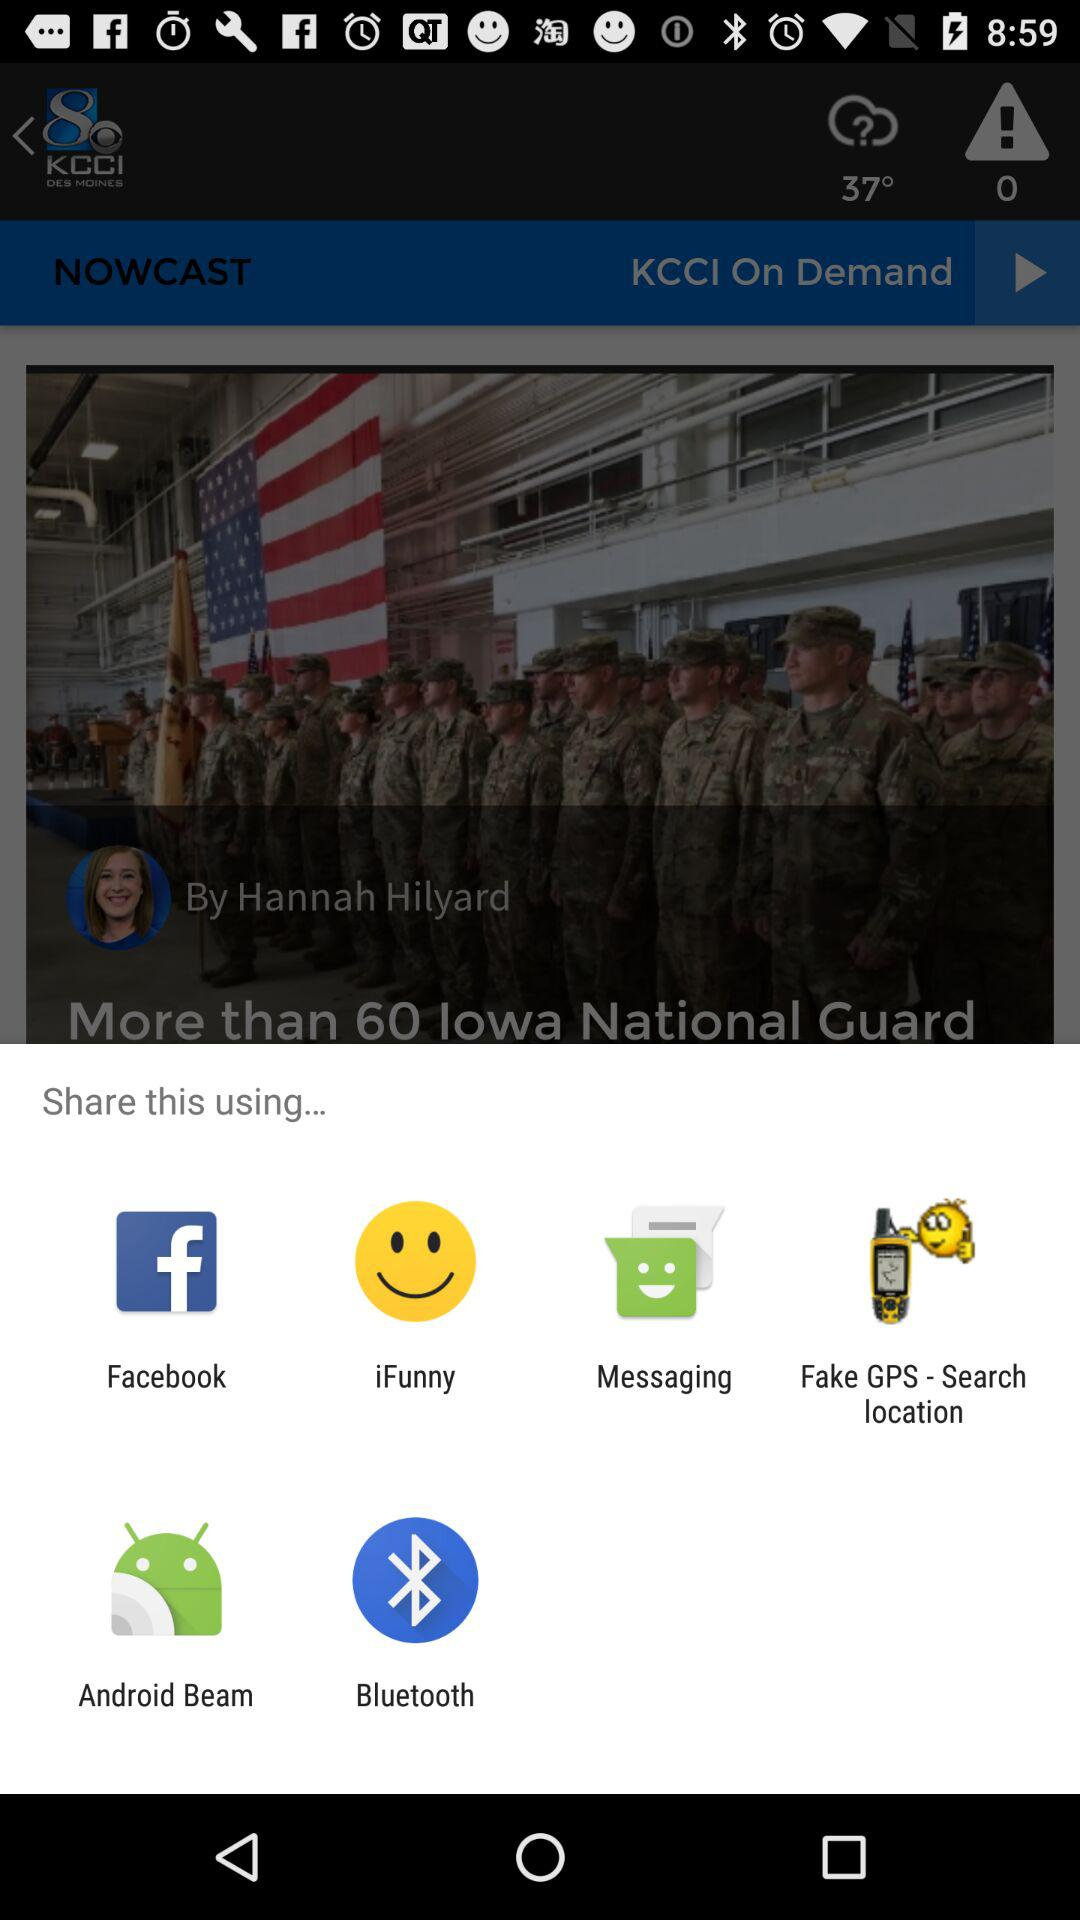What is the reporter's name? The reporter's name is Hannah Hilyard. 